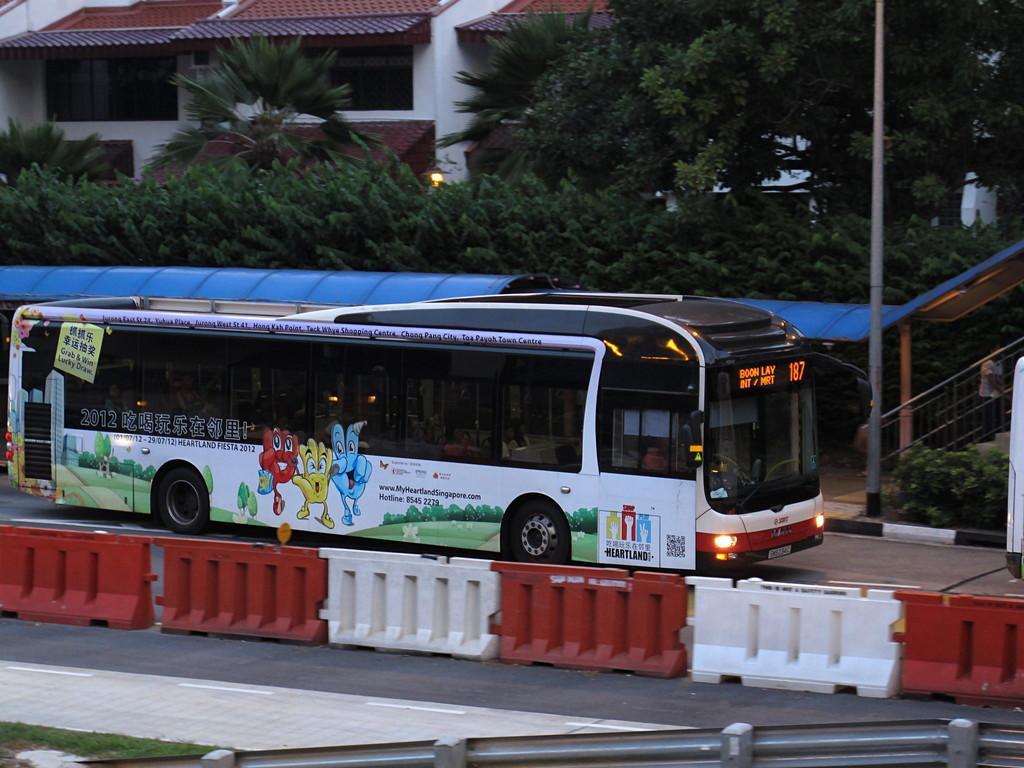In one or two sentences, can you explain what this image depicts? In this image, we can see a vehicle, a person. We can see some buildings, trees and the ground with some objects. We can also see the railing and an object on the right. We can see some grass and some objects at the bottom. We can see the shed. 